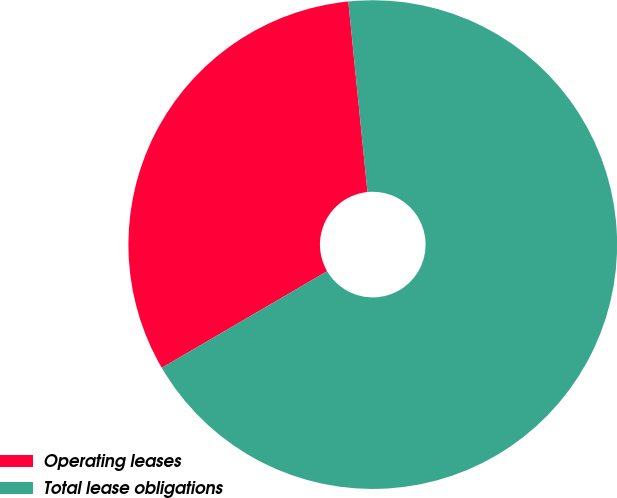<chart> <loc_0><loc_0><loc_500><loc_500><pie_chart><fcel>Operating leases<fcel>Total lease obligations<nl><fcel>31.82%<fcel>68.18%<nl></chart> 